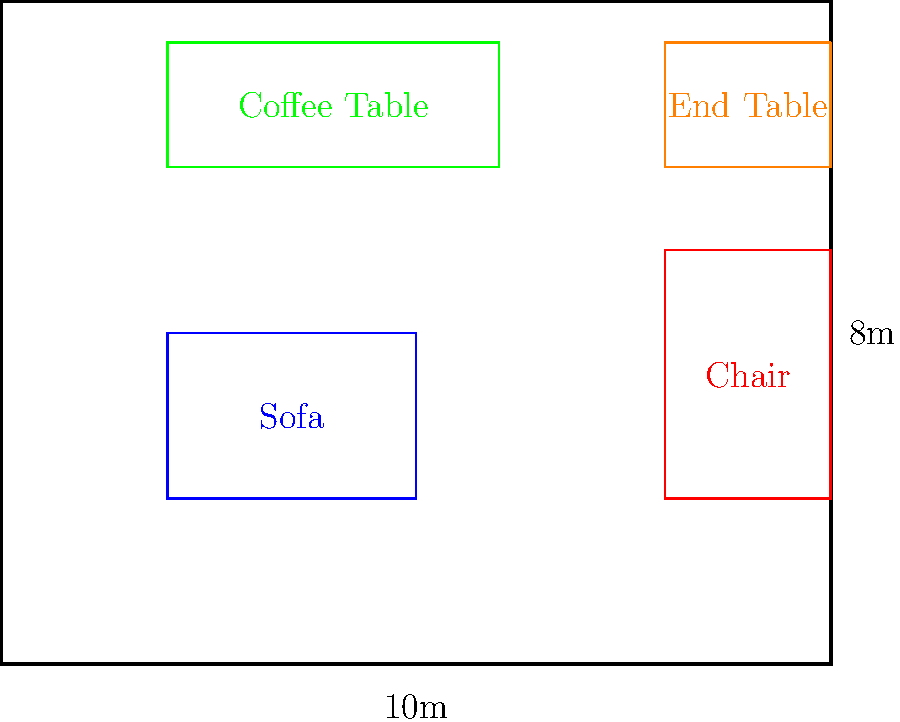In a luxury living room measuring 10m x 8m, you need to arrange a sofa (3m x 2m), an armchair (2m x 3m), a coffee table (4m x 1.5m), and an end table (2m x 1.5m). What is the maximum number of possible arrangements that maintain at least 1m clearance between furniture pieces and walls, while ensuring the coffee table is centered in front of the sofa? To solve this problem, we need to follow these steps:

1. Determine the available space:
   - Room size: 10m x 8m
   - Effective space (accounting for 1m clearance): 8m x 6m

2. Analyze furniture placement constraints:
   - Sofa (3m x 2m): Can be placed along any wall
   - Armchair (2m x 3m): Can be placed in corners or along walls
   - Coffee table (4m x 1.5m): Must be centered in front of the sofa
   - End table (2m x 1.5m): Can be placed next to the sofa or armchair

3. Calculate possible sofa positions:
   - Along 8m wall: 6 positions (8m - 3m + 1 = 6)
   - Along 6m wall: 4 positions (6m - 3m + 1 = 4)
   - Total sofa positions: 6 + 4 + 6 + 4 = 20

4. For each sofa position, determine coffee table placement:
   - Coffee table must be centered in front of the sofa
   - Only 1 position per sofa placement

5. Calculate armchair positions for each sofa+coffee table arrangement:
   - Typically 2-3 positions per arrangement

6. Place the end table:
   - Usually 1-2 positions per arrangement

7. Multiply the number of possibilities:
   - Approximate calculation: 20 (sofa positions) x 1 (coffee table) x 2.5 (average armchair positions) x 1.5 (average end table positions) = 75

The exact number may vary slightly depending on specific arrangements, but this calculation provides a reasonable estimate.
Answer: Approximately 75 arrangements 